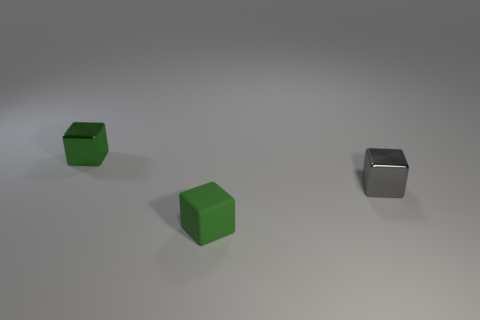How many green cubes must be subtracted to get 1 green cubes? 1 Add 3 small cubes. How many objects exist? 6 Subtract all small brown blocks. Subtract all small cubes. How many objects are left? 0 Add 2 matte cubes. How many matte cubes are left? 3 Add 2 tiny green matte cubes. How many tiny green matte cubes exist? 3 Subtract 1 green blocks. How many objects are left? 2 